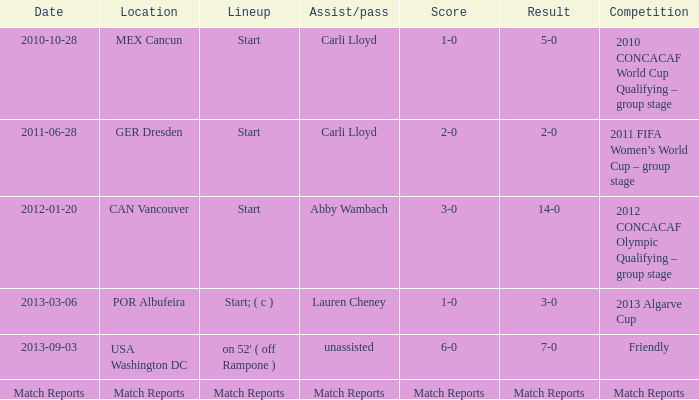Where has a score of match reports? Match Reports. 